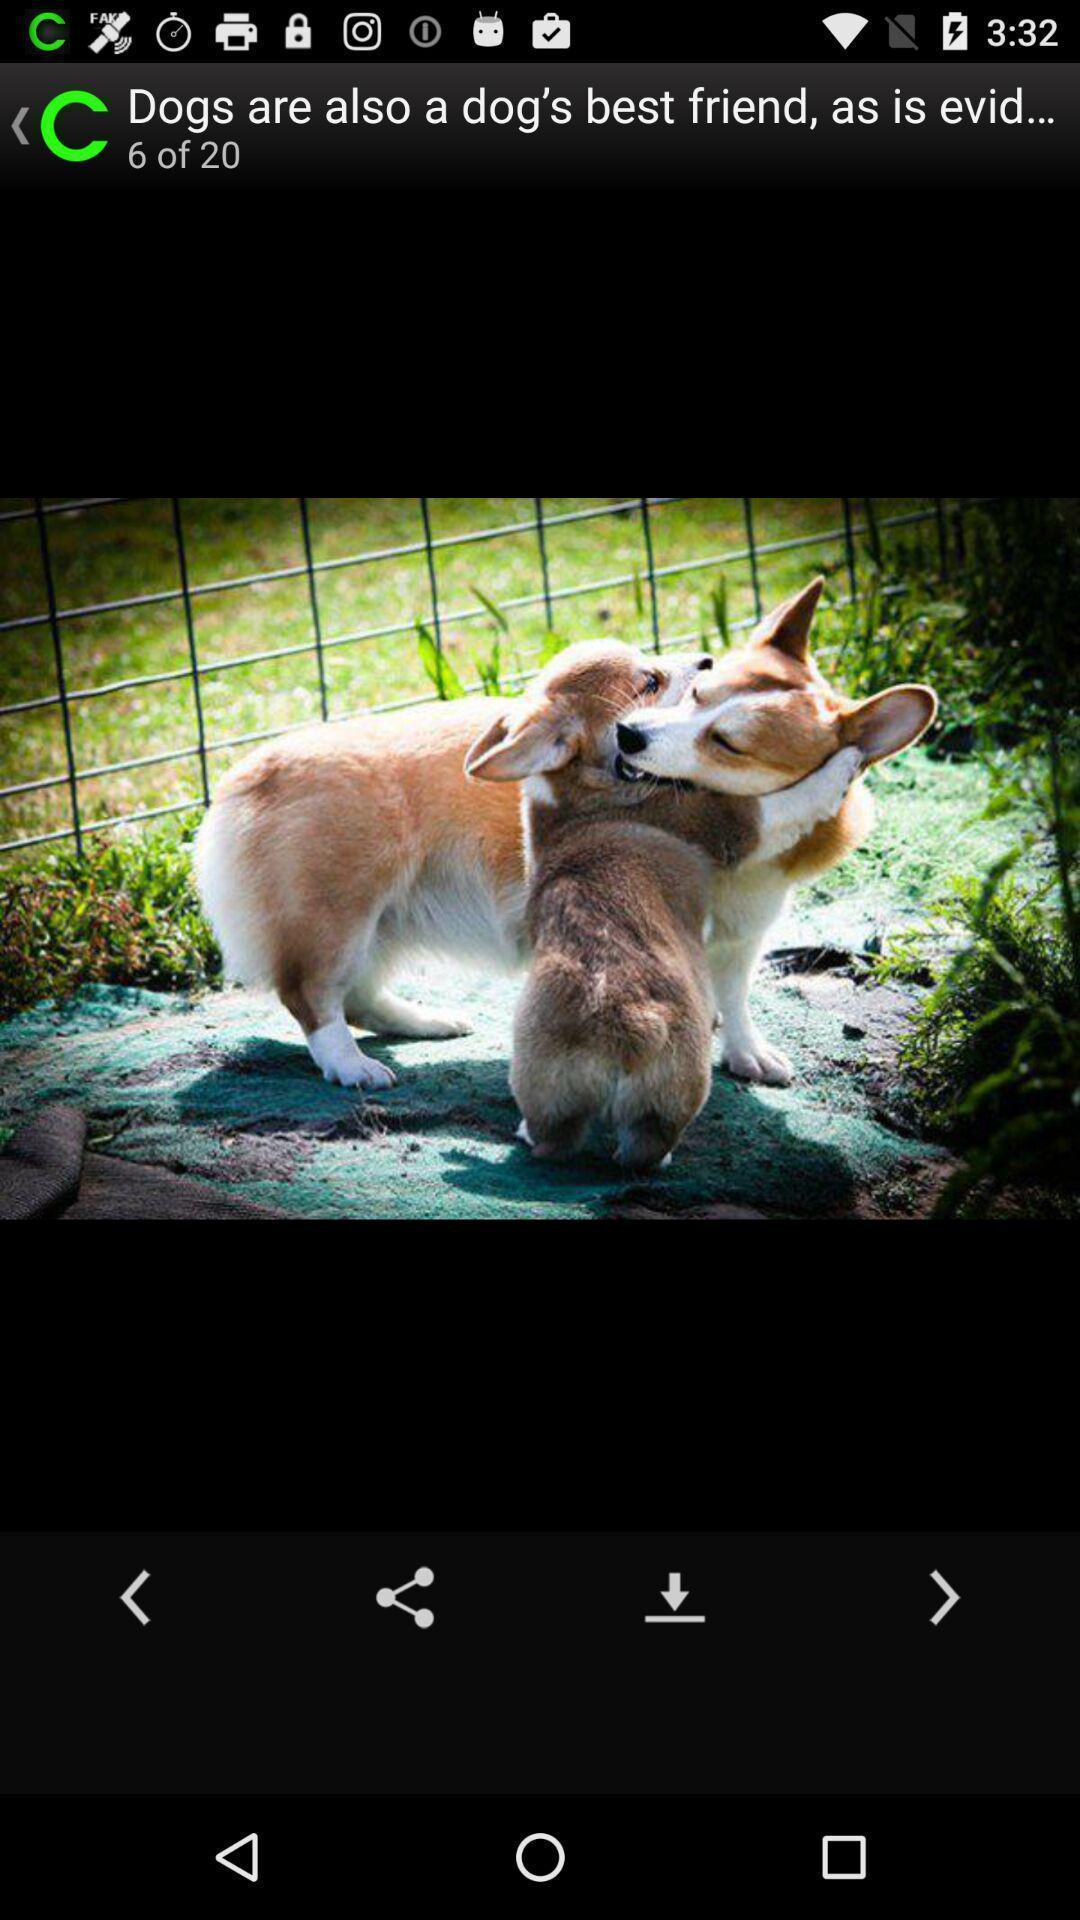Describe the visual elements of this screenshot. Page displayed with a picture to share and download. 